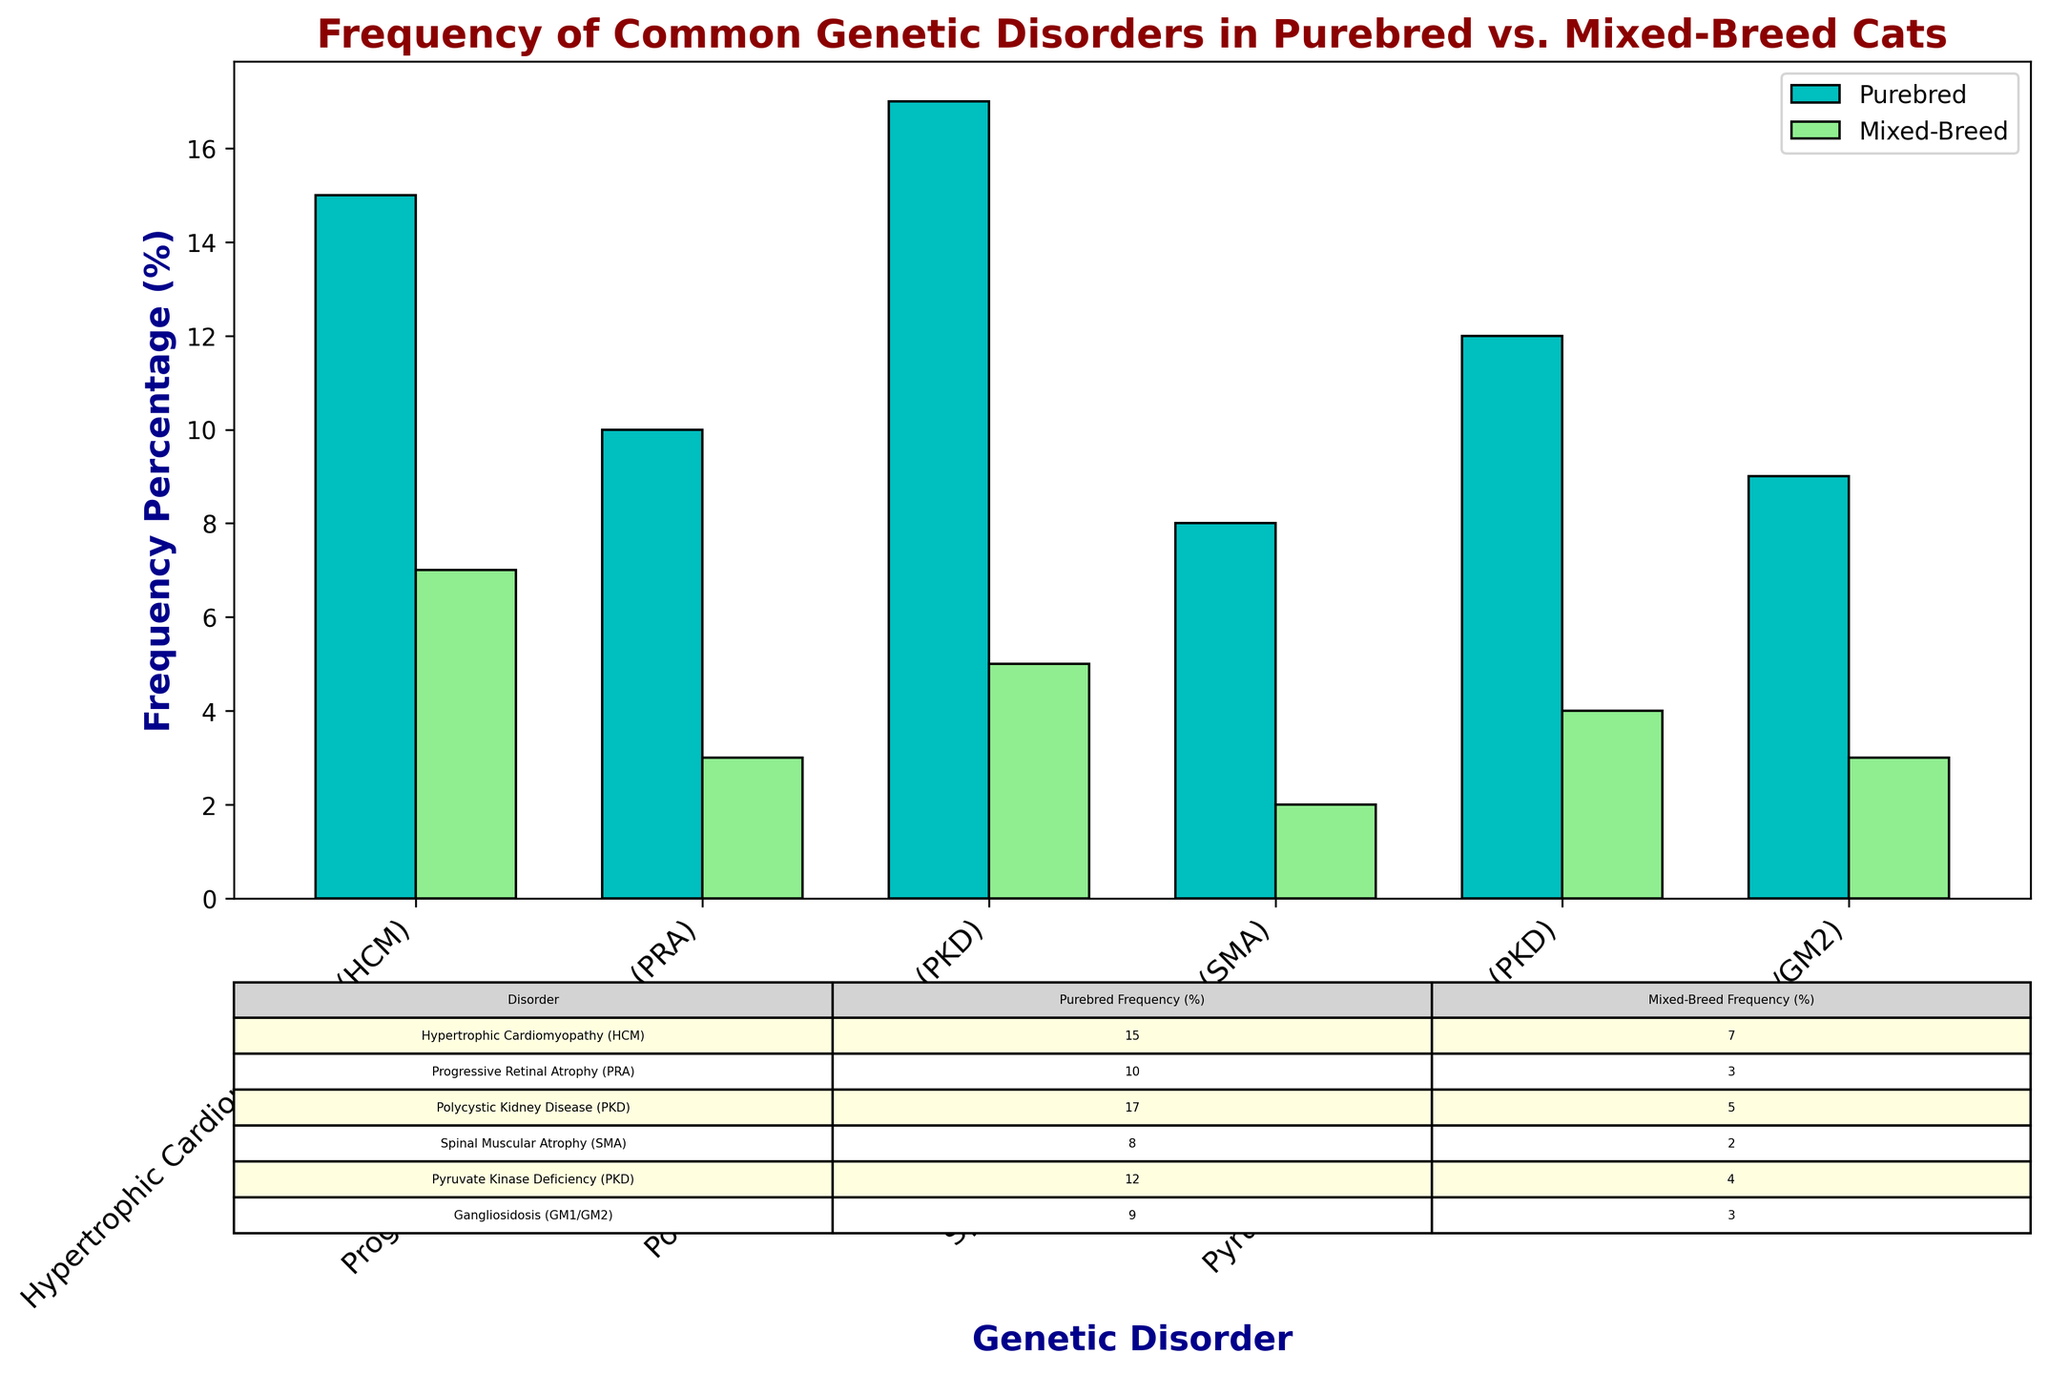Which breed has a higher frequency of Hypertrophic Cardiomyopathy (HCM)? By comparing the bar heights for Hypertrophic Cardiomyopathy (HCM), Purebred cats have a noticeably higher bar than Mixed-Breed cats. The table confirms that Purebred cats have a frequency of 15%, while Mixed-Breed cats have 7%.
Answer: Purebred What is the difference in the frequency percentage of Polycystic Kidney Disease (PKD) between Purebred and Mixed-Breed cats? The table shows that Purebred cats have a frequency of 17%, while Mixed-Breed cats have a frequency of 5%. Subtracting these values: 17% - 5% = 12%.
Answer: 12% Which genetic disorder has the smallest difference in frequency percentage between Purebred and Mixed-Breed cats? By looking through the table, the smallest difference in frequency percentage is for Spinal Muscular Atrophy (SMA), with Purebred cats at 8% and Mixed-Breed cats at 2%, resulting in a difference of 6%.
Answer: Spinal Muscular Atrophy (SMA) How many genetic disorders have a frequency percentage of 10% or higher in Purebred cats? The table lists the frequency percentages for each disorder in Purebred cats: 15%, 10%, 17%, 8%, 12%, and 9%. Adding up only those 10% or higher: HCM, PRA, PKD, and Pyruvate Kinase Deficiency, gives us four disorders.
Answer: 4 Are there any genetic disorders where Mixed-Breed cats have a frequency percentage higher than Purebred cats? By reviewing each pair of bars and the table values, in all cases (HCM, PRA, PKD, SMA, Pyruvate Kinase Deficiency, Gangliosidosis), Purebred cats have higher frequencies, making the answer no.
Answer: No What is the visual difference in bar color between Purebred and Mixed-Breed cats? Purebred cats' bars are colored cyan, and Mixed-Breed cats' bars are light green. These colors help differentiate between the two categories visually.
Answer: Cyan vs. Light Green What is the total frequency percentage of all genetic disorders in Mixed-Breed cats? Sum the frequency percentages for Mixed-Breed cats: 7% (HCM) + 3% (PRA) + 5% (PKD) + 2% (SMA) + 4% (Pyruvate Kinase Deficiency) + 3% (Gangliosidosis) = 24%.
Answer: 24% Which breed has a higher overall frequency percentage when considering all genetic disorders combined? Sum the frequency percentages for both breeds. Purebred: 15% + 10% + 17% + 8% + 12% + 9% = 71%. Mixed-Breed: 7% + 3% + 5% + 2% + 4% + 3% = 24%. Comparing these totals, Purebred cats have a higher overall frequency.
Answer: Purebred Which genetic disorder shows the highest frequency percentage in Purebred cats? In the table, the highest frequency percentage for Purebred cats is Polycystic Kidney Disease (PKD) at 17%.
Answer: Polycystic Kidney Disease (PKD) What is the ratio of the frequency percentage of Progressive Retinal Atrophy (PRA) between Purebred and Mixed-Breed cats? For Progressive Retinal Atrophy (PRA), Purebred cats have a frequency of 10% and Mixed-Breed cats have a frequency of 3%. The ratio is 10% / 3% which simplifies to approximately 3.33.
Answer: 3.33 